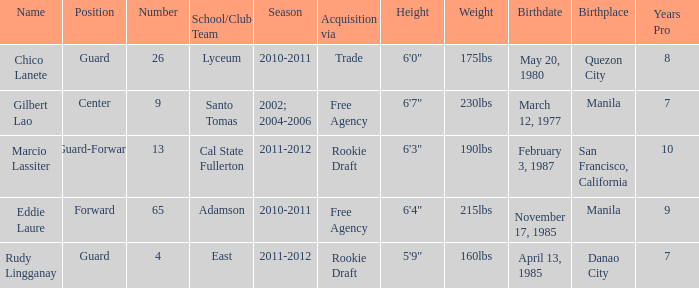What number has an acquisition via the Rookie Draft, and is part of a School/club team at Cal State Fullerton? 13.0. 